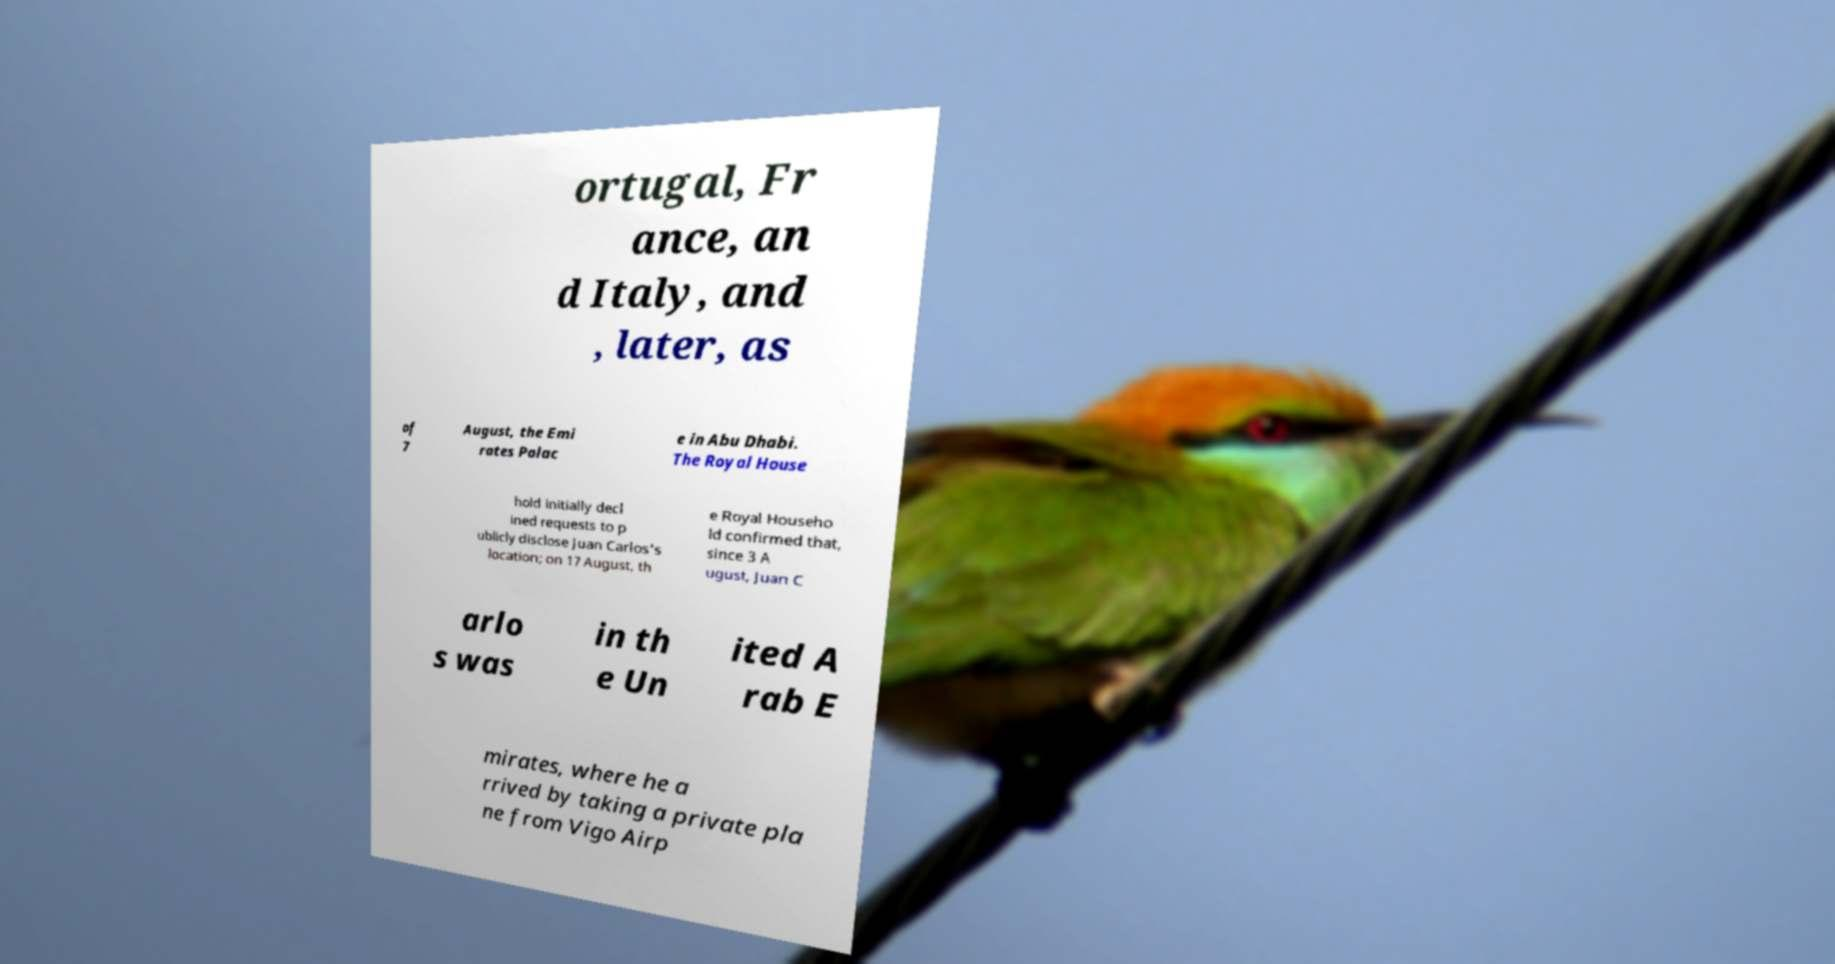I need the written content from this picture converted into text. Can you do that? ortugal, Fr ance, an d Italy, and , later, as of 7 August, the Emi rates Palac e in Abu Dhabi. The Royal House hold initially decl ined requests to p ublicly disclose Juan Carlos's location; on 17 August, th e Royal Househo ld confirmed that, since 3 A ugust, Juan C arlo s was in th e Un ited A rab E mirates, where he a rrived by taking a private pla ne from Vigo Airp 